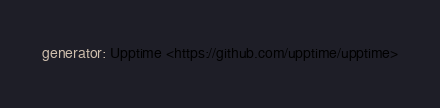Convert code to text. <code><loc_0><loc_0><loc_500><loc_500><_YAML_>generator: Upptime <https://github.com/upptime/upptime>
</code> 